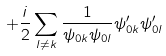Convert formula to latex. <formula><loc_0><loc_0><loc_500><loc_500>+ \frac { i } { 2 } \sum _ { l \neq k } \frac { 1 } { \psi _ { 0 k } \psi _ { 0 l } } \psi _ { 0 k } ^ { \prime } \psi _ { 0 l } ^ { \prime }</formula> 